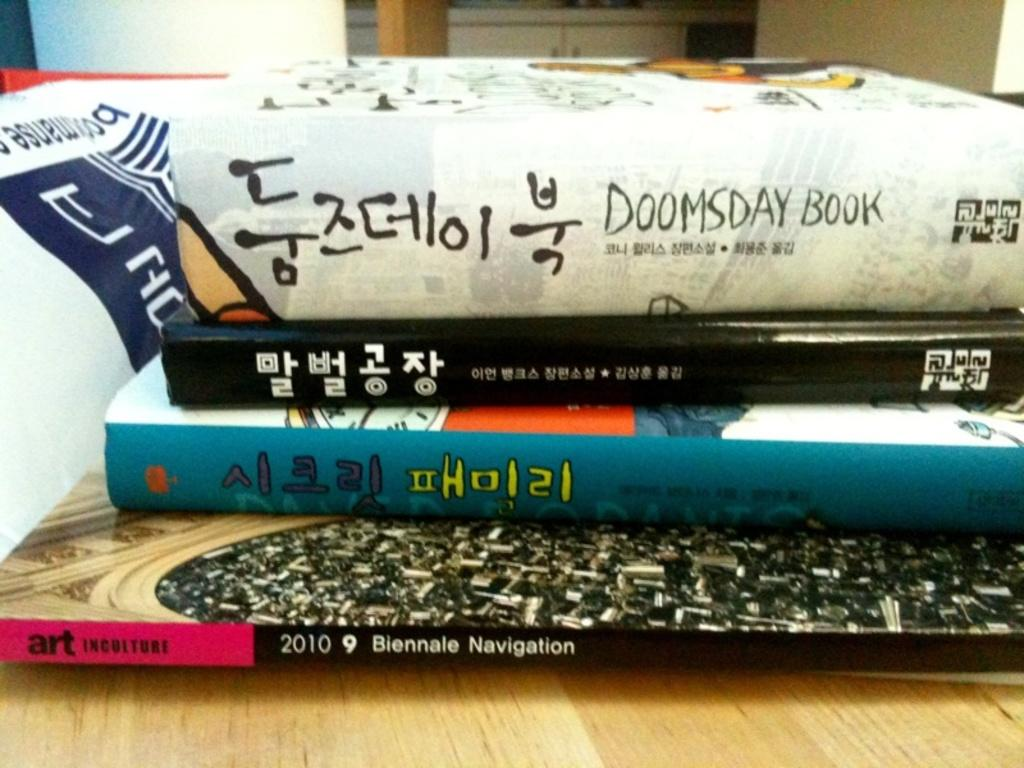Provide a one-sentence caption for the provided image. Four books stacked on top of one another with a book named "Doomsday Book" on top. 